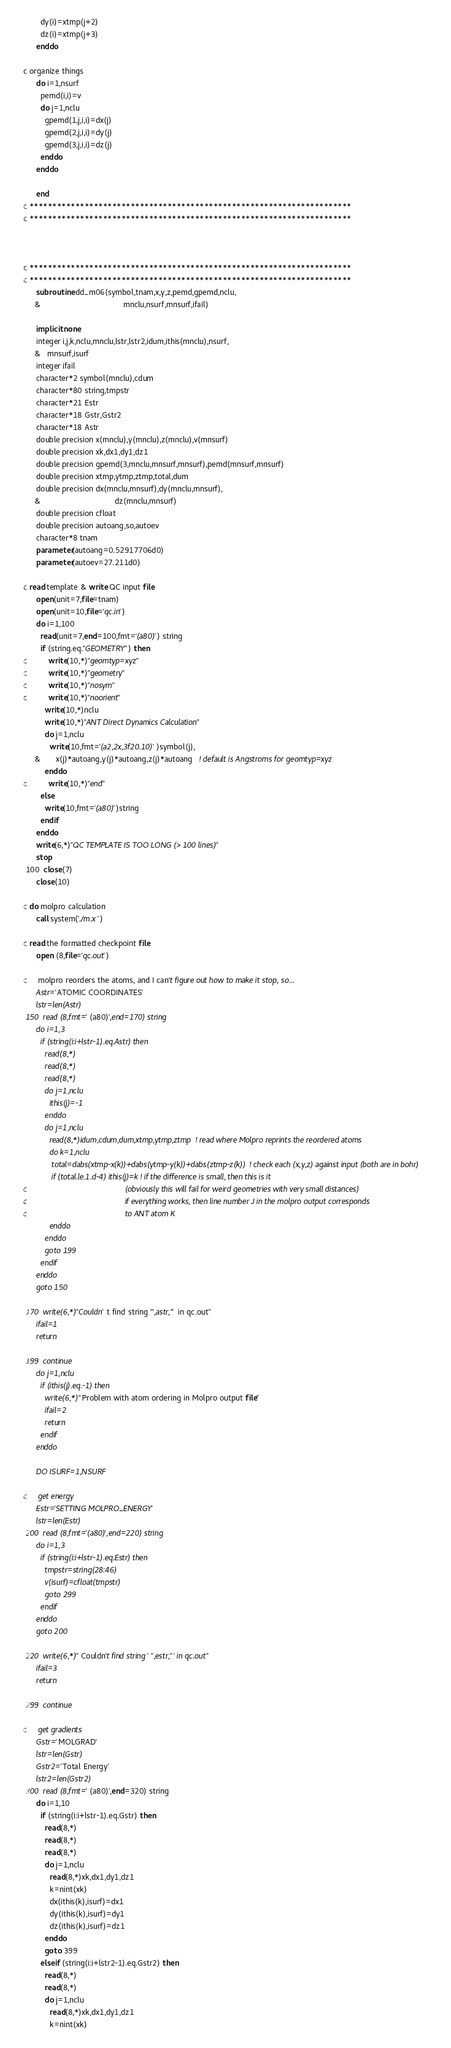Convert code to text. <code><loc_0><loc_0><loc_500><loc_500><_FORTRAN_>        dy(i)=xtmp(j+2)
        dz(i)=xtmp(j+3)
      enddo

c organize things
      do i=1,nsurf
        pemd(i,i)=v
        do j=1,nclu
          gpemd(1,j,i,i)=dx(j)
          gpemd(2,j,i,i)=dy(j)
          gpemd(3,j,i,i)=dz(j)
        enddo
      enddo

      end
c **********************************************************************
c **********************************************************************



c **********************************************************************
c **********************************************************************
      subroutine dd_m06(symbol,tnam,x,y,z,pemd,gpemd,nclu,
     &                                      mnclu,nsurf,mnsurf,ifail)

      implicit none
      integer i,j,k,nclu,mnclu,lstr,lstr2,idum,ithis(mnclu),nsurf,
     &   mnsurf,isurf
      integer ifail
      character*2 symbol(mnclu),cdum
      character*80 string,tmpstr
      character*21 Estr
      character*18 Gstr,Gstr2
      character*18 Astr
      double precision x(mnclu),y(mnclu),z(mnclu),v(mnsurf)
      double precision xk,dx1,dy1,dz1
      double precision gpemd(3,mnclu,mnsurf,mnsurf),pemd(mnsurf,mnsurf)
      double precision xtmp,ytmp,ztmp,total,dum
      double precision dx(mnclu,mnsurf),dy(mnclu,mnsurf),
     &                                  dz(mnclu,mnsurf)
      double precision cfloat
      double precision autoang,so,autoev
      character*8 tnam
      parameter(autoang=0.52917706d0)
      parameter(autoev=27.211d0)

c read template & write QC input file
      open(unit=7,file=tnam)
      open(unit=10,file='qc.in')
      do i=1,100
        read(unit=7,end=100,fmt='(a80)') string
        if (string.eq."GEOMETRY") then
c          write(10,*)"geomtyp=xyz"
c          write(10,*)"geometry"
c          write(10,*)"nosym"
c          write(10,*)"noorient"
          write(10,*)nclu
          write(10,*)"ANT Direct Dynamics Calculation"
          do j=1,nclu
            write(10,fmt='(a2,2x,3f20.10)')symbol(j),
     &       x(j)*autoang,y(j)*autoang,z(j)*autoang   ! default is Angstroms for geomtyp=xyz
          enddo
c          write(10,*)"end"
        else
          write(10,fmt='(a80)')string
        endif
      enddo
      write(6,*)"QC TEMPLATE IS TOO LONG (> 100 lines)"
      stop
 100  close(7)
      close(10)

c do molpro calculation
      call system('./m.x ')

c read the formatted checkpoint file
      open (8,file='qc.out')

c     molpro reorders the atoms, and I can't figure out how to make it stop, so...
      Astr='ATOMIC COORDINATES'
      lstr=len(Astr)
 150  read (8,fmt='(a80)',end=170) string
      do i=1,3
        if (string(i:i+lstr-1).eq.Astr) then
          read(8,*)
          read(8,*)
          read(8,*)
          do j=1,nclu
            ithis(j)=-1
          enddo
          do j=1,nclu
            read(8,*)idum,cdum,dum,xtmp,ytmp,ztmp  ! read where Molpro reprints the reordered atoms
            do k=1,nclu
             total=dabs(xtmp-x(k))+dabs(ytmp-y(k))+dabs(ztmp-z(k))  ! check each (x,y,z) against input (both are in bohr)
             if (total.le.1.d-4) ithis(j)=k ! if the difference is small, then this is it 
c                                             (obviously this will fail for weird geometries with very small distances)
c                                             if everything works, then line number J in the molpro output corresponds
c                                             to ANT atom K
            enddo
          enddo
          goto 199
        endif
      enddo
      goto 150

 170  write(6,*)"Couldn't find string '",astr,"' in qc.out"
      ifail=1
      return

 199  continue
      do j=1,nclu
        if (ithis(j).eq.-1) then
          write(6,*)"Problem with atom ordering in Molpro output file"
          ifail=2
          return
        endif
      enddo

      DO ISURF=1,NSURF

c     get energy
      Estr='SETTING MOLPRO_ENERGY'
      lstr=len(Estr)
 200  read (8,fmt='(a80)',end=220) string
      do i=1,3
        if (string(i:i+lstr-1).eq.Estr) then
          tmpstr=string(28:46)
          v(isurf)=cfloat(tmpstr)
          goto 299
        endif
      enddo
      goto 200

 220  write(6,*)"Couldn't find string '",estr,"' in qc.out"
      ifail=3
      return

 299  continue

c     get gradients
      Gstr='MOLGRAD'
      lstr=len(Gstr)
      Gstr2='Total Energy'
      lstr2=len(Gstr2)
 300  read (8,fmt='(a80)',end=320) string
      do i=1,10
        if (string(i:i+lstr-1).eq.Gstr) then
          read(8,*)
          read(8,*)
          read(8,*)
          do j=1,nclu
            read(8,*)xk,dx1,dy1,dz1
            k=nint(xk)
            dx(ithis(k),isurf)=dx1
            dy(ithis(k),isurf)=dy1
            dz(ithis(k),isurf)=dz1
          enddo
          goto 399
        elseif (string(i:i+lstr2-1).eq.Gstr2) then
          read(8,*)
          read(8,*)
          do j=1,nclu
            read(8,*)xk,dx1,dy1,dz1
            k=nint(xk)</code> 